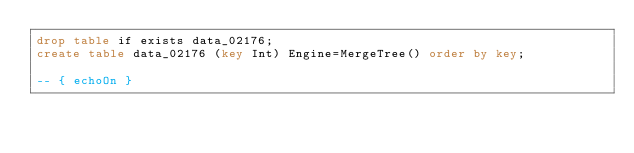<code> <loc_0><loc_0><loc_500><loc_500><_SQL_>drop table if exists data_02176;
create table data_02176 (key Int) Engine=MergeTree() order by key;

-- { echoOn }
</code> 